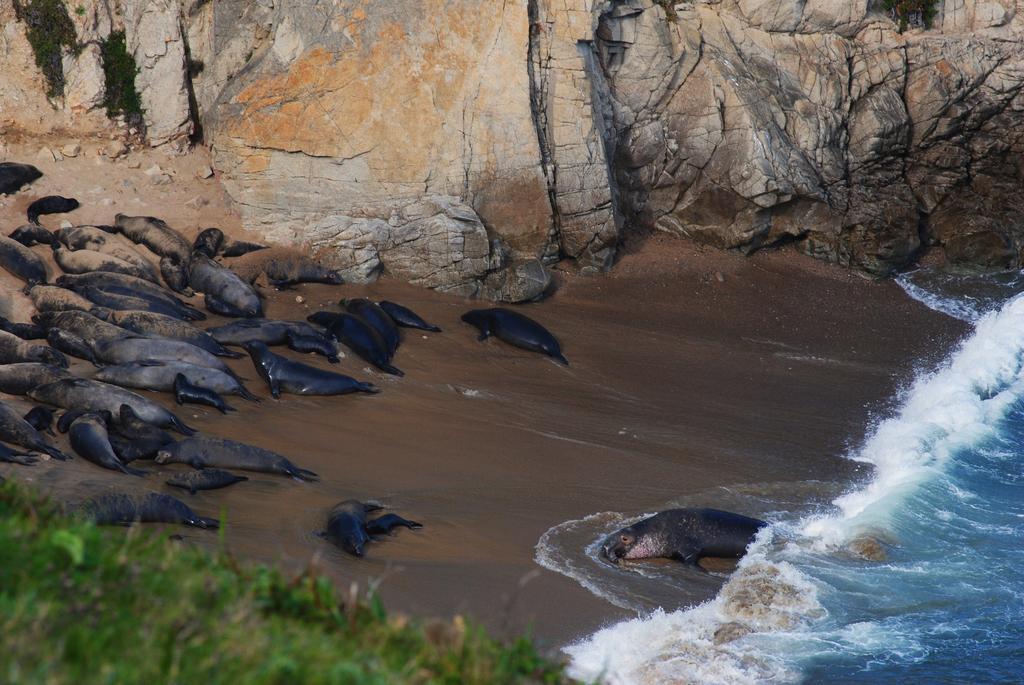How would you summarize this image in a sentence or two? At the bottom of the image there are leaves. Behind that on the seashore there are few seals. On the right side of the image there is water. At the top of the image there are rocks. 